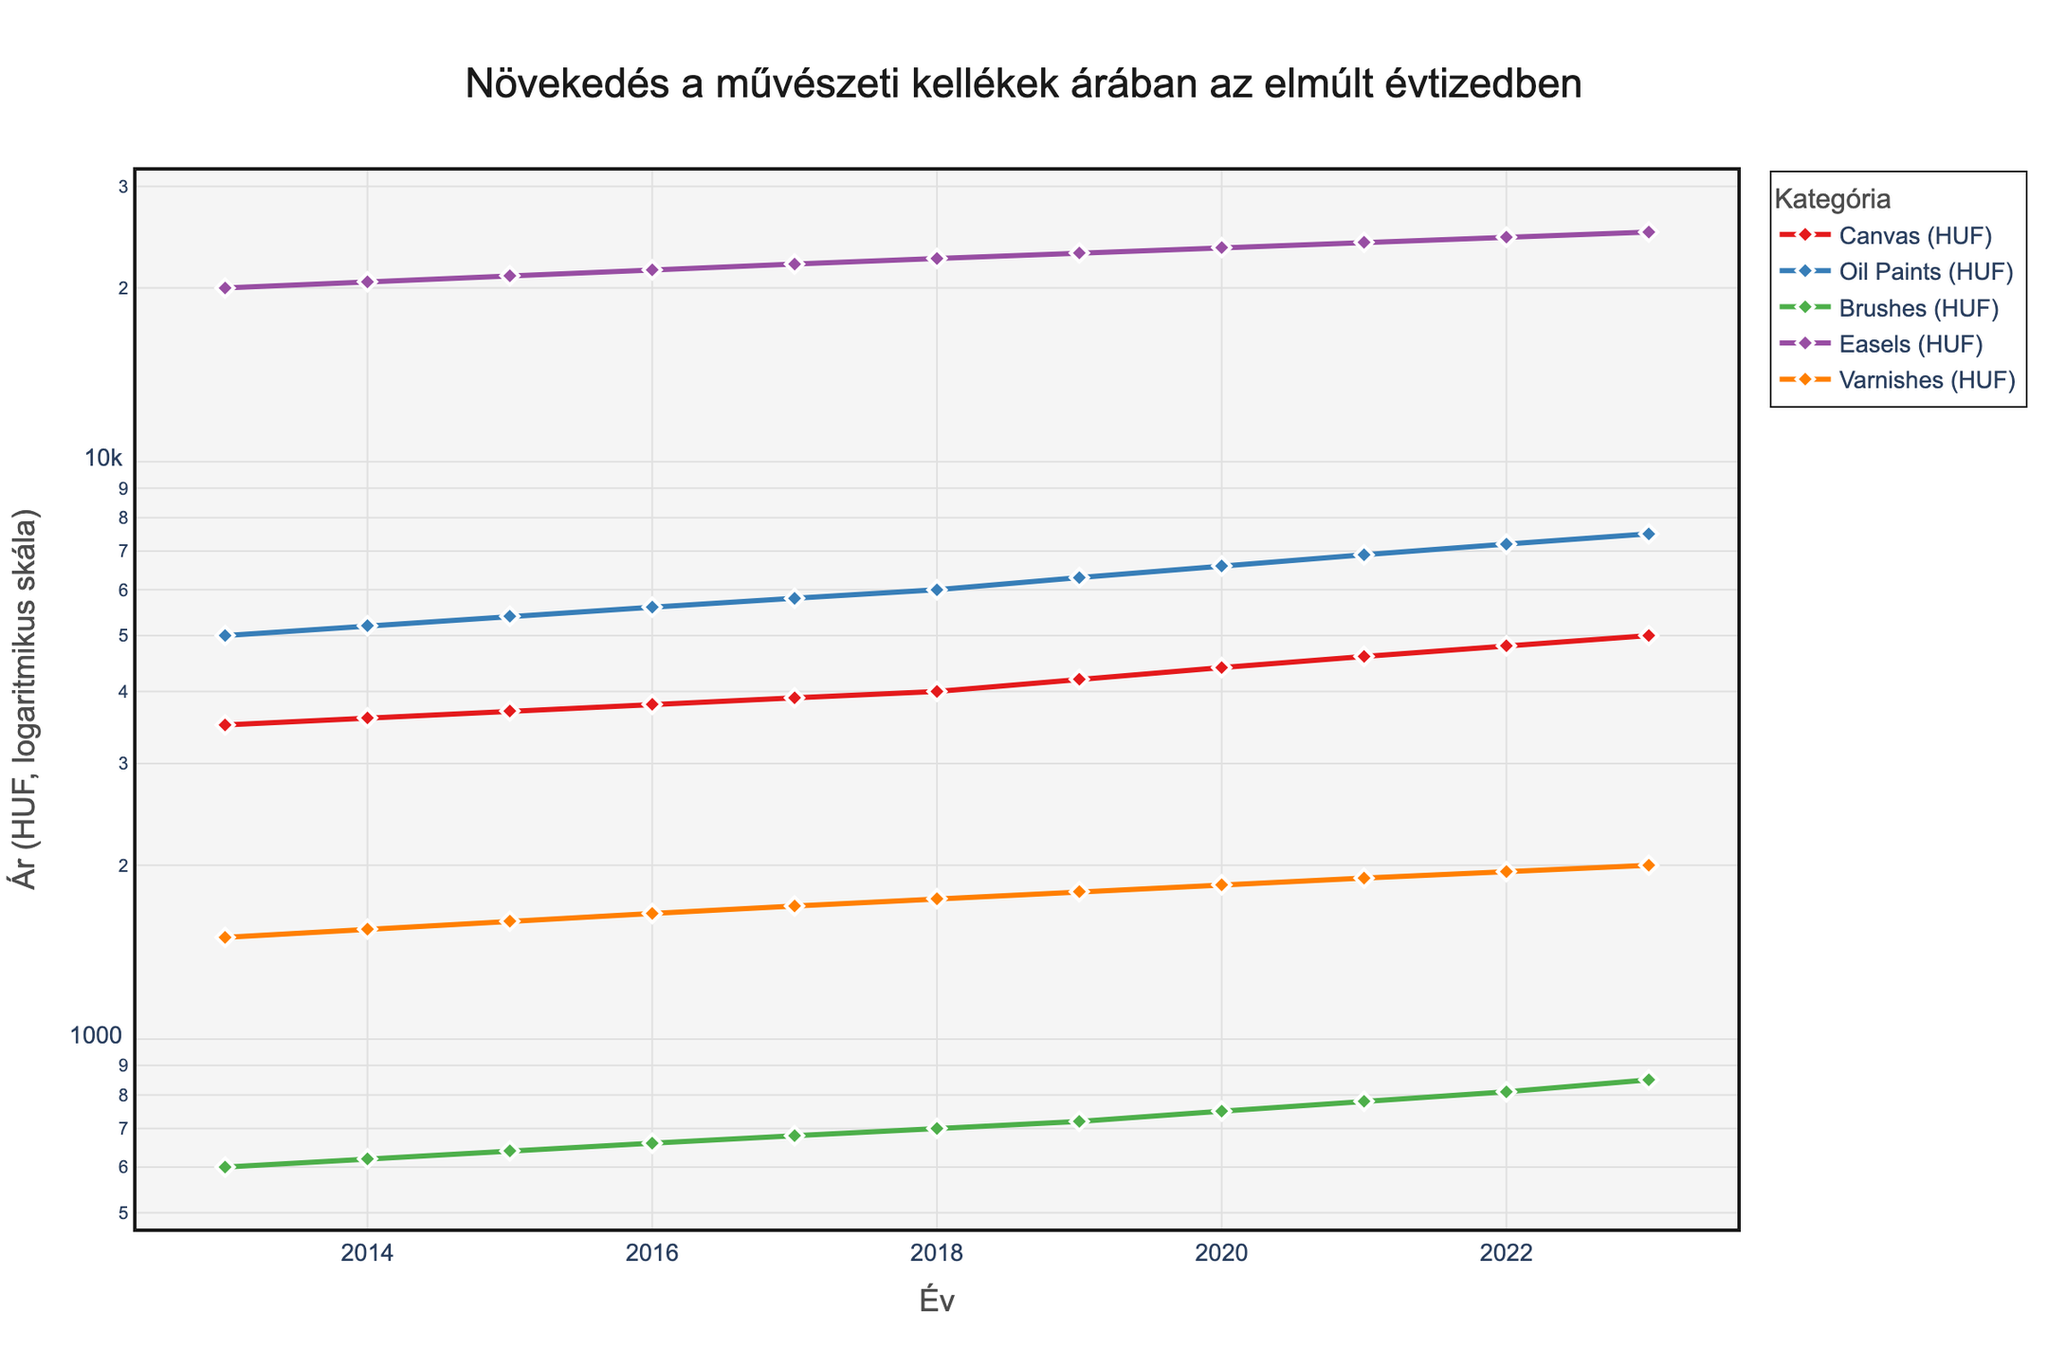What is the title of the figure? The title can be found at the top of the figure. It reads "Növekedés a művészeti kellékek árában az elmúlt évtizedben," which translates to "Growth of Art Supply Prices over the Past Decade."
Answer: Növekedés a művészeti kellékek árában az elmúlt évtizedben What does the y-axis represent in the figure? The y-axis title reads "Ár (HUF, logaritmikus skála)," which means "Price (HUF, logarithmic scale)". This indicates that prices are measured in Hungarian Forints (HUF) on a log scale.
Answer: Price (HUF, logarithmic scale) Which category experienced the greatest price increase from 2013 to 2023? By visually comparing the lines, we observe that all categories show an upward trend. The "Easels" category (orange line) appears to have the steepest slope, indicating the largest price increase.
Answer: Easels Which year did the prices of Oil Paints cross 6000 HUF? Locate the line corresponding to "Oil Paints" (blue line) and find where it first rises above the 6000 HUF mark. This occurs between 2017 and 2018.
Answer: 2018 What is the price of Brushes in 2020? Look for the data point on the line corresponding to "Brushes" (green line) at year 2020. The price is 750 HUF.
Answer: 750 HUF How do the prices of Easels in 2020 compare to those in 2013? Compare the price of "Easels" in 2020 (23500 HUF) to the price in 2013 (20000 HUF). Calculate the percentage increase: ((23500 - 20000) / 20000) * 100 = 17.5%.
Answer: 17.5% Among Canvas and Varnishes, which item had a higher price increase from 2019 to 2023 and by how much? Calculate the difference for both:
Canvas: 5000 - 4200 = 800 HUF 
Varnishes: 2000 - 1800 = 200 HUF 
Canvas had a higher price increase.
Answer: Canvas, 800 HUF Which category has the least fluctuation in prices over the years? Examine the lines' smoothness and slope. "Brushes" (green line) remains relatively flat compared to other categories, indicating minimal fluctuation.
Answer: Brushes What is the price difference between Oil Paints and Varnishes in 2023? Find the 2023 data points for "Oil Paints" (7500 HUF) and "Varnishes" (2000 HUF) and subtract the two: 7500 - 2000 = 5500 HUF.
Answer: 5500 HUF "How does the use of a logarithmic scale affect the interpretation of price trends?" A logarithmic scale compresses the range, making it easier to compare growth rates across different magnitudes. It emphasizes proportional growth rather than absolute differences, revealing exponential trends more clearly.
Answer: Emphasizes proportional growth 